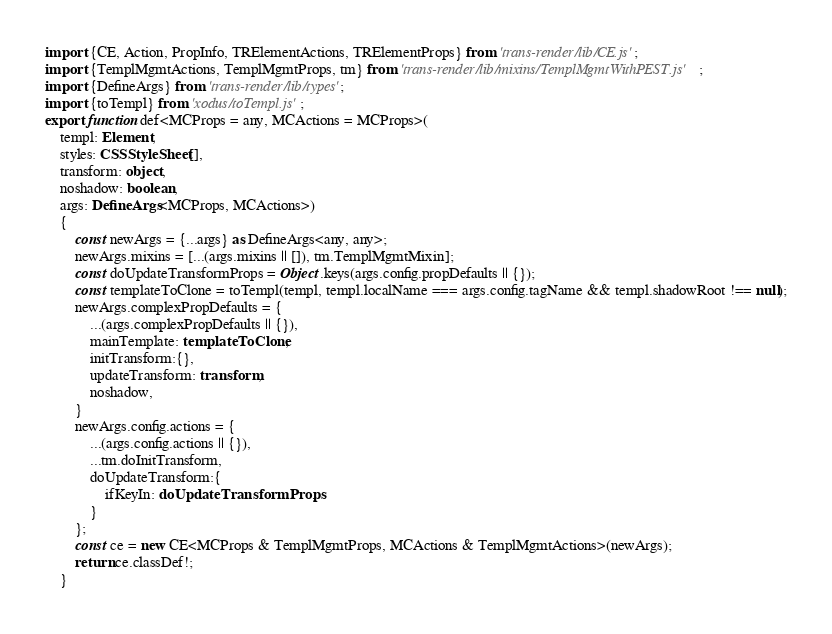<code> <loc_0><loc_0><loc_500><loc_500><_TypeScript_>import {CE, Action, PropInfo, TRElementActions, TRElementProps} from 'trans-render/lib/CE.js';
import {TemplMgmtActions, TemplMgmtProps, tm} from 'trans-render/lib/mixins/TemplMgmtWithPEST.js';
import {DefineArgs} from 'trans-render/lib/types';
import {toTempl} from 'xodus/toTempl.js';
export function def<MCProps = any, MCActions = MCProps>(
    templ: Element,
    styles: CSSStyleSheet[],
    transform: object,
    noshadow: boolean,
    args: DefineArgs<MCProps, MCActions>)
    {
        const newArgs = {...args} as DefineArgs<any, any>;
        newArgs.mixins = [...(args.mixins || []), tm.TemplMgmtMixin];
        const doUpdateTransformProps = Object.keys(args.config.propDefaults || {});
        const templateToClone = toTempl(templ, templ.localName === args.config.tagName && templ.shadowRoot !== null);
        newArgs.complexPropDefaults = {
            ...(args.complexPropDefaults || {}),
            mainTemplate: templateToClone,
            initTransform:{},
            updateTransform: transform,
            noshadow,
        }
        newArgs.config.actions = {
            ...(args.config.actions || {}),
            ...tm.doInitTransform,
            doUpdateTransform:{
                ifKeyIn: doUpdateTransformProps,
            }
        };
        const ce = new CE<MCProps & TemplMgmtProps, MCActions & TemplMgmtActions>(newArgs);
        return ce.classDef!;
    }</code> 